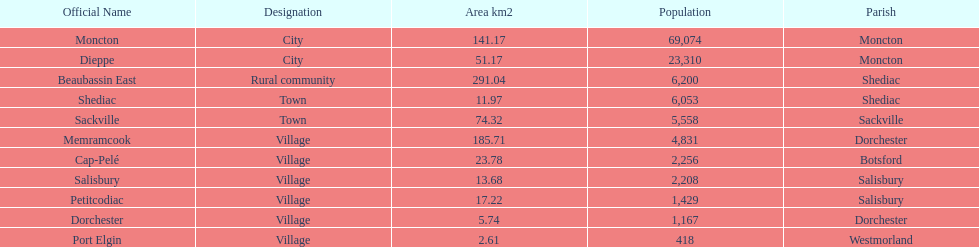Could you parse the entire table as a dict? {'header': ['Official Name', 'Designation', 'Area km2', 'Population', 'Parish'], 'rows': [['Moncton', 'City', '141.17', '69,074', 'Moncton'], ['Dieppe', 'City', '51.17', '23,310', 'Moncton'], ['Beaubassin East', 'Rural community', '291.04', '6,200', 'Shediac'], ['Shediac', 'Town', '11.97', '6,053', 'Shediac'], ['Sackville', 'Town', '74.32', '5,558', 'Sackville'], ['Memramcook', 'Village', '185.71', '4,831', 'Dorchester'], ['Cap-Pelé', 'Village', '23.78', '2,256', 'Botsford'], ['Salisbury', 'Village', '13.68', '2,208', 'Salisbury'], ['Petitcodiac', 'Village', '17.22', '1,429', 'Salisbury'], ['Dorchester', 'Village', '5.74', '1,167', 'Dorchester'], ['Port Elgin', 'Village', '2.61', '418', 'Westmorland']]} Municipality in the same parish of moncton Dieppe. 